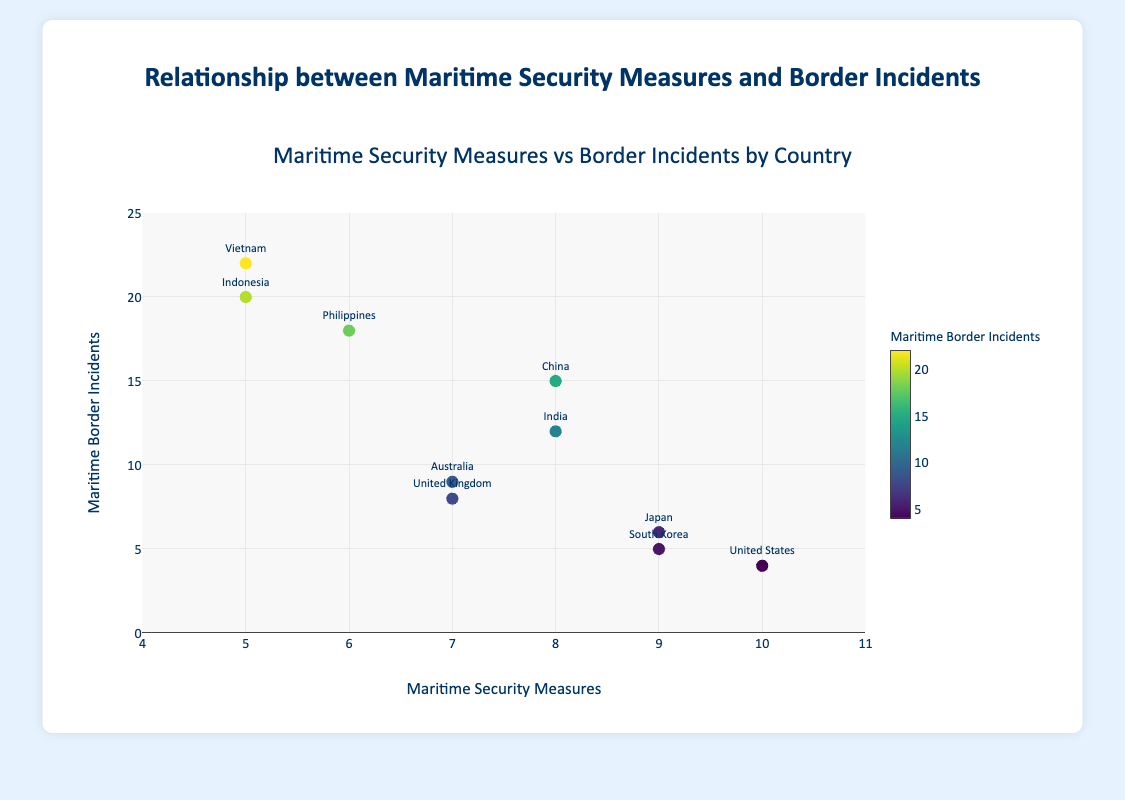What is the title of the plot? The title is displayed at the top of the plot. It reads "Maritime Security Measures vs Border Incidents by Country".
Answer: Maritime Security Measures vs Border Incidents by Country How many countries are represented in the plot? Count the number of distinct data points labeled with country names. There are 10 distinct countries.
Answer: 10 Which country has the highest number of maritime border incidents? Identify the country label with the highest value on the y-axis, in this case, Vietnam with 22 incidents.
Answer: Vietnam What is the relationship between maritime security measures and border incidents for Japan? Locate Japan's data point and note its coordinates: 9 for security measures and 6 for border incidents.
Answer: 9 security measures, 6 border incidents Which countries have maritime security measures greater than 8? Look for countries with x-values (security measures) greater than 8. Identified: United States, Japan, South Korea.
Answer: United States, Japan, South Korea What is the average maritime border incidents for countries with security measures of 7? Find countries with security measures of 7 and calculate the average of their incidents: Australia (9) and United Kingdom (8), average is (9+8)/2 = 8.5.
Answer: 8.5 How does India compare with China in terms of maritime border incidents? India has 12 incidents, China has 15. India has 3 fewer incidents than China.
Answer: India has 3 fewer incidents than China Which has more maritime security measures, the U.S. or India? Compare the x-values for the U.S. (10) and India (8). The U.S. has more.
Answer: The U.S What is the median number of maritime border incidents among the countries? Arrange the incidents in numerical order: 4, 5, 6, 8, 9, 12, 15, 18, 20, 22. The median is the middle value for an even set, average of 6th and 7th value (12 and 15): (12+15) / 2 = 13.5.
Answer: 13.5 Do higher maritime security measures correlate with fewer incidents? Observe the general trend; higher security measures (8-10) tend to correspond to fewer incidents (4-12). There appears to be a negative correlation.
Answer: Yes 